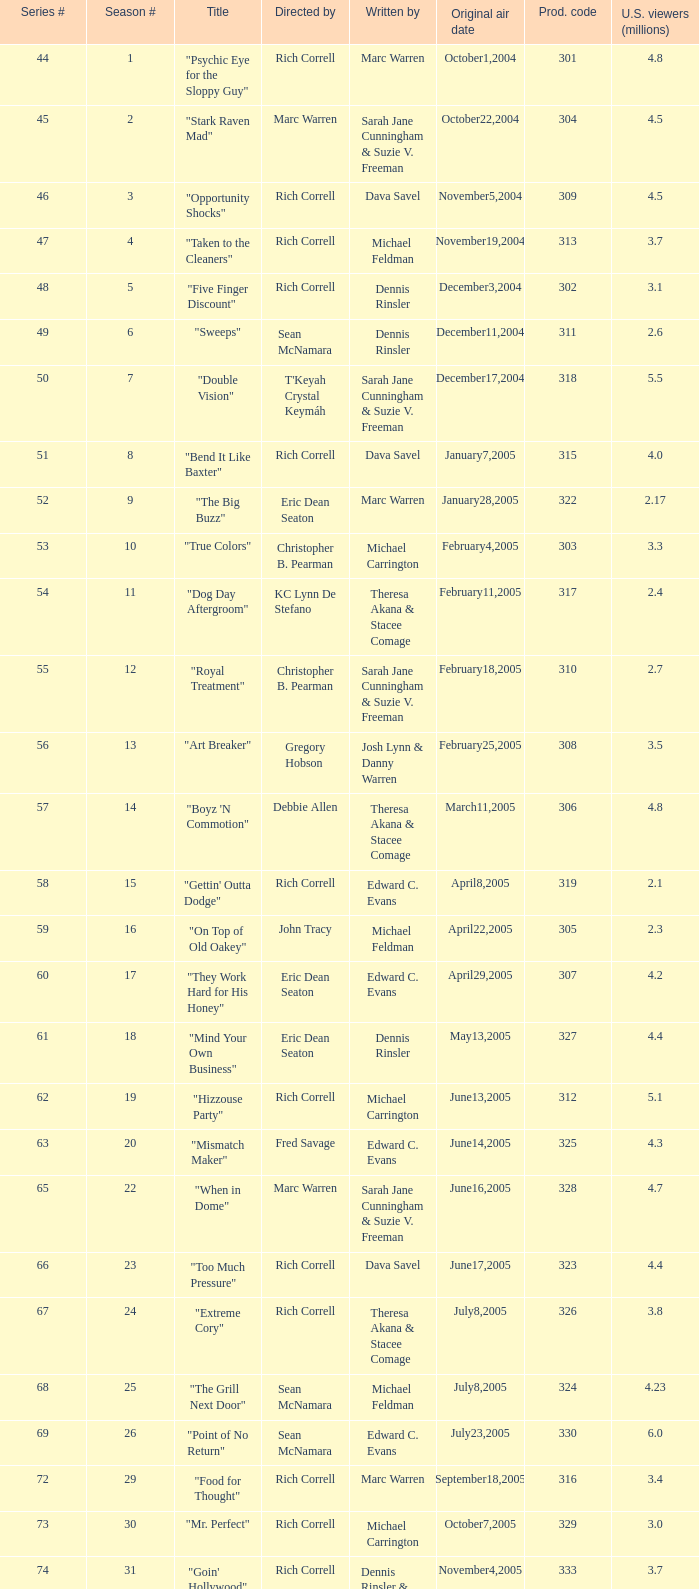What is the title of the episode directed by Rich Correll and written by Dennis Rinsler? "Five Finger Discount". 